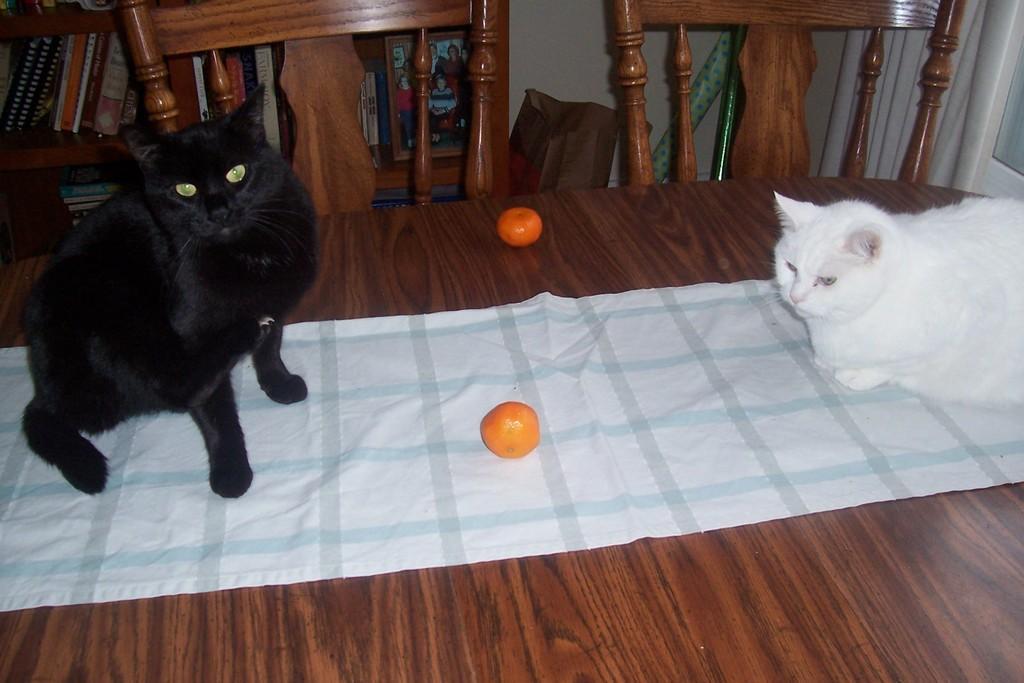Describe this image in one or two sentences. In this image there is a table, on that table there is a black cat and white cat, in the middle there are two fruits in the background there are two chairs and a shelf in that shelf there are books and photo frame. 